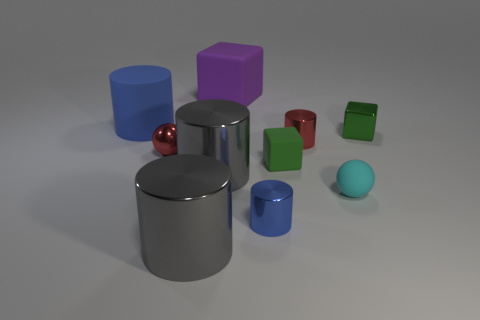What purpose do these objects serve, and could they be part of a larger set? The objects in the image seem to be simple geometric shapes, often used for educational or decorative purposes. They may be teaching tools for explaining geometry or part of a design set meant to enhance the visual interest of a space. 